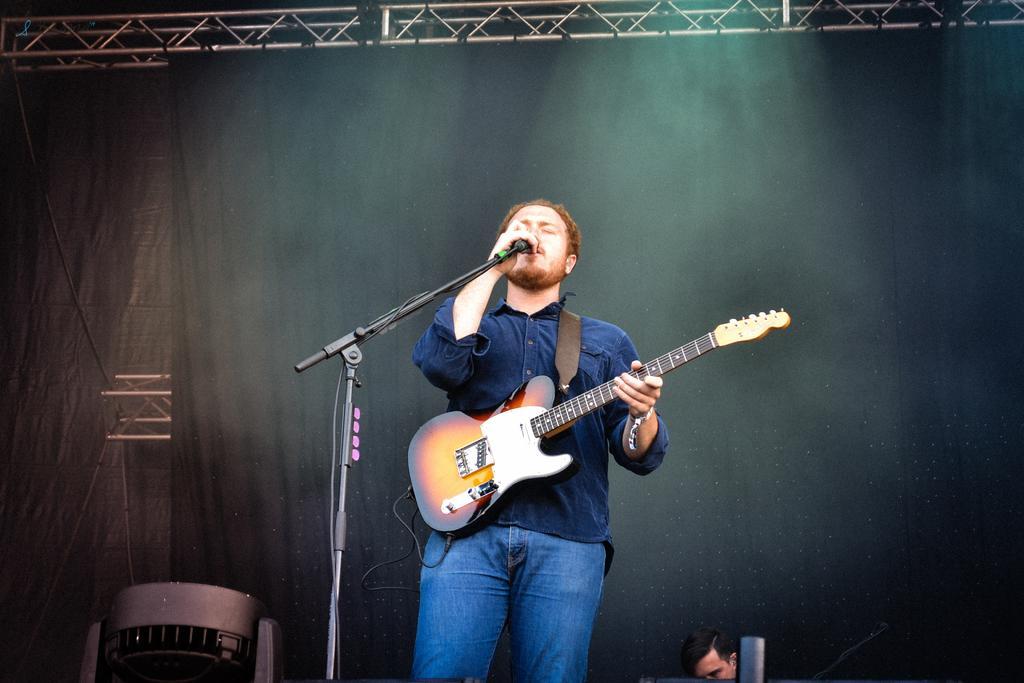How would you summarize this image in a sentence or two? In this image a man wearing a blue shirt is singing. He is holding a mic. He is carrying a guitar. Behind him there is a curtain. Here a person is visible. 